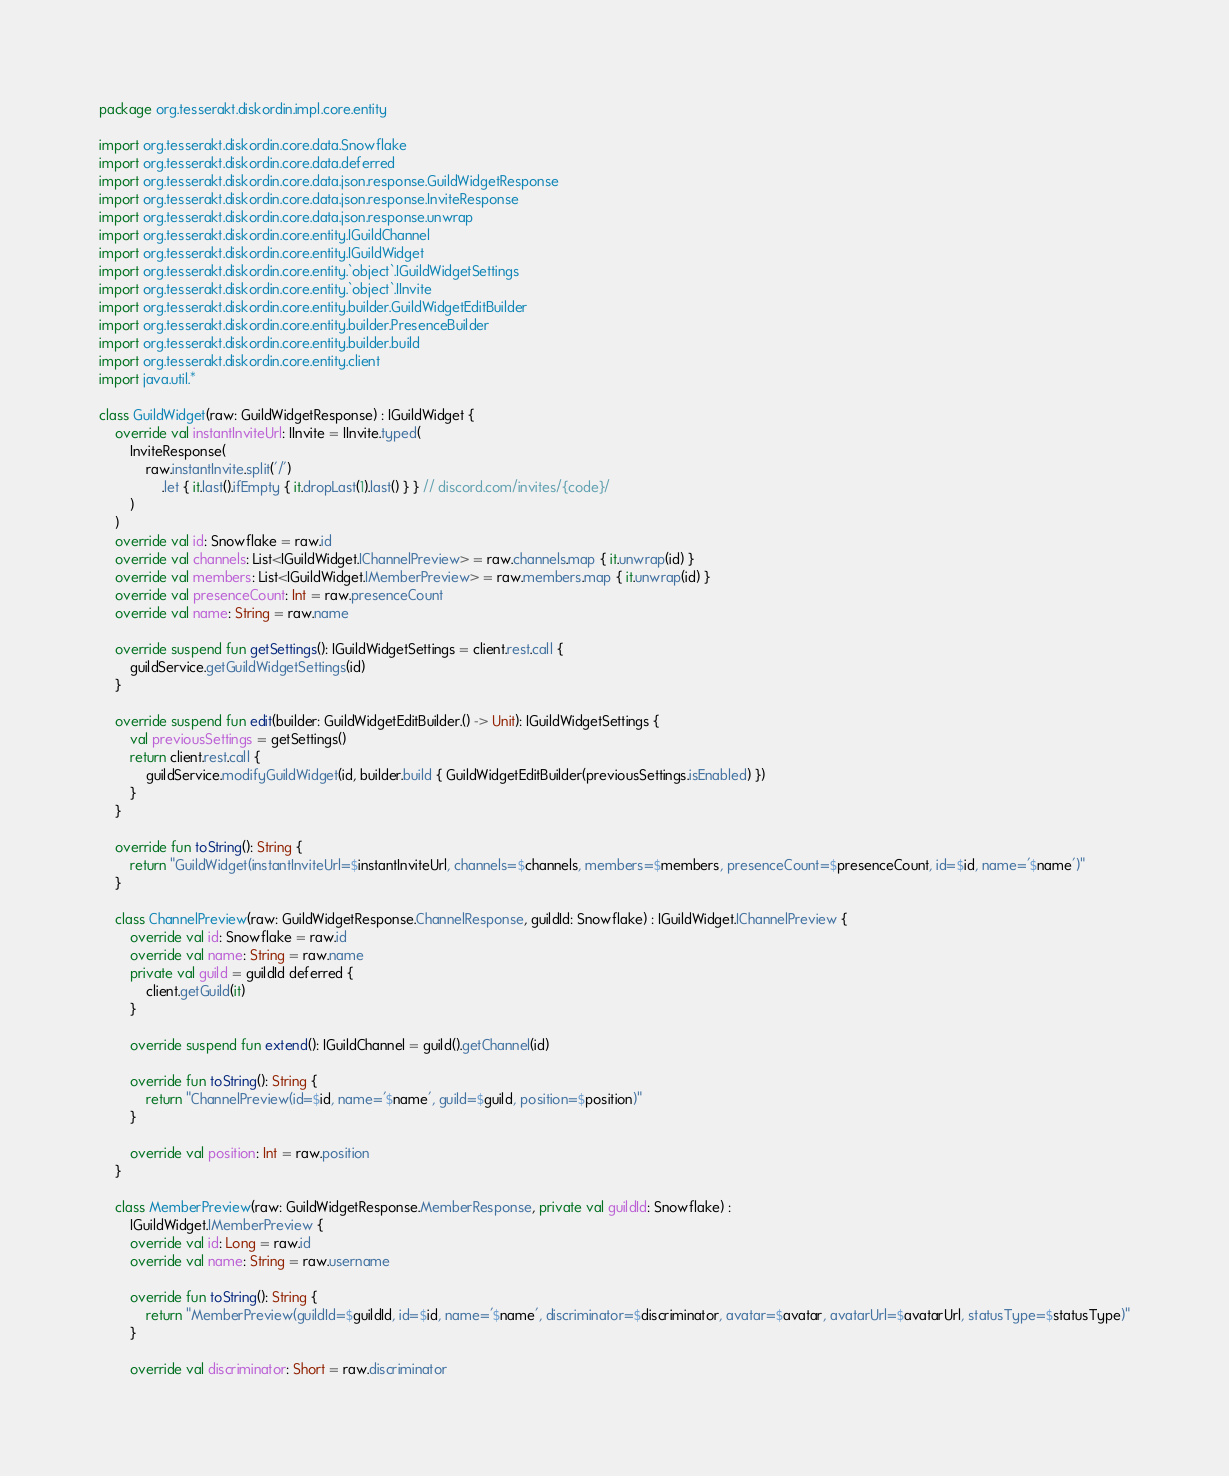<code> <loc_0><loc_0><loc_500><loc_500><_Kotlin_>package org.tesserakt.diskordin.impl.core.entity

import org.tesserakt.diskordin.core.data.Snowflake
import org.tesserakt.diskordin.core.data.deferred
import org.tesserakt.diskordin.core.data.json.response.GuildWidgetResponse
import org.tesserakt.diskordin.core.data.json.response.InviteResponse
import org.tesserakt.diskordin.core.data.json.response.unwrap
import org.tesserakt.diskordin.core.entity.IGuildChannel
import org.tesserakt.diskordin.core.entity.IGuildWidget
import org.tesserakt.diskordin.core.entity.`object`.IGuildWidgetSettings
import org.tesserakt.diskordin.core.entity.`object`.IInvite
import org.tesserakt.diskordin.core.entity.builder.GuildWidgetEditBuilder
import org.tesserakt.diskordin.core.entity.builder.PresenceBuilder
import org.tesserakt.diskordin.core.entity.builder.build
import org.tesserakt.diskordin.core.entity.client
import java.util.*

class GuildWidget(raw: GuildWidgetResponse) : IGuildWidget {
    override val instantInviteUrl: IInvite = IInvite.typed(
        InviteResponse(
            raw.instantInvite.split('/')
                .let { it.last().ifEmpty { it.dropLast(1).last() } } // discord.com/invites/{code}/
        )
    )
    override val id: Snowflake = raw.id
    override val channels: List<IGuildWidget.IChannelPreview> = raw.channels.map { it.unwrap(id) }
    override val members: List<IGuildWidget.IMemberPreview> = raw.members.map { it.unwrap(id) }
    override val presenceCount: Int = raw.presenceCount
    override val name: String = raw.name

    override suspend fun getSettings(): IGuildWidgetSettings = client.rest.call {
        guildService.getGuildWidgetSettings(id)
    }

    override suspend fun edit(builder: GuildWidgetEditBuilder.() -> Unit): IGuildWidgetSettings {
        val previousSettings = getSettings()
        return client.rest.call {
            guildService.modifyGuildWidget(id, builder.build { GuildWidgetEditBuilder(previousSettings.isEnabled) })
        }
    }

    override fun toString(): String {
        return "GuildWidget(instantInviteUrl=$instantInviteUrl, channels=$channels, members=$members, presenceCount=$presenceCount, id=$id, name='$name')"
    }

    class ChannelPreview(raw: GuildWidgetResponse.ChannelResponse, guildId: Snowflake) : IGuildWidget.IChannelPreview {
        override val id: Snowflake = raw.id
        override val name: String = raw.name
        private val guild = guildId deferred {
            client.getGuild(it)
        }

        override suspend fun extend(): IGuildChannel = guild().getChannel(id)

        override fun toString(): String {
            return "ChannelPreview(id=$id, name='$name', guild=$guild, position=$position)"
        }

        override val position: Int = raw.position
    }

    class MemberPreview(raw: GuildWidgetResponse.MemberResponse, private val guildId: Snowflake) :
        IGuildWidget.IMemberPreview {
        override val id: Long = raw.id
        override val name: String = raw.username

        override fun toString(): String {
            return "MemberPreview(guildId=$guildId, id=$id, name='$name', discriminator=$discriminator, avatar=$avatar, avatarUrl=$avatarUrl, statusType=$statusType)"
        }

        override val discriminator: Short = raw.discriminator</code> 